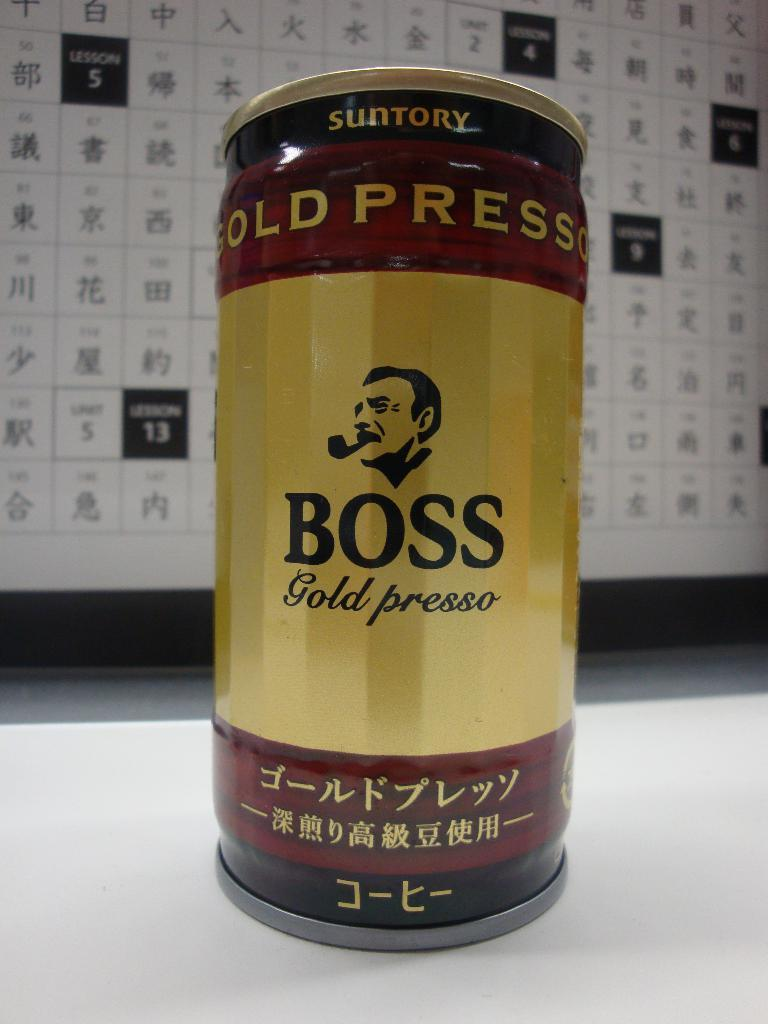Provide a one-sentence caption for the provided image. A can of BOSS gold presso with the image of a man's head smoking a pipe. 